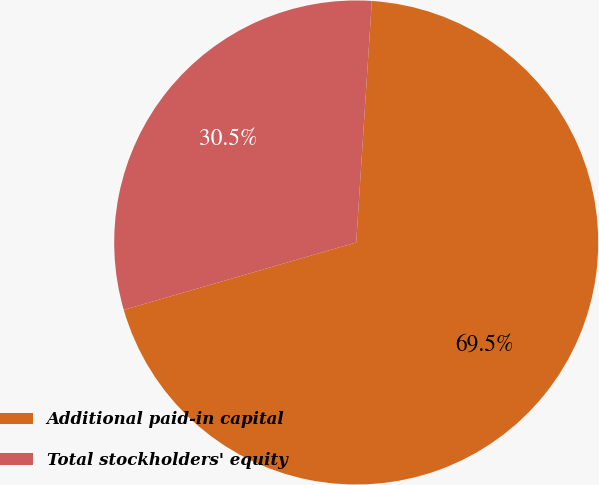Convert chart. <chart><loc_0><loc_0><loc_500><loc_500><pie_chart><fcel>Additional paid-in capital<fcel>Total stockholders' equity<nl><fcel>69.48%<fcel>30.52%<nl></chart> 